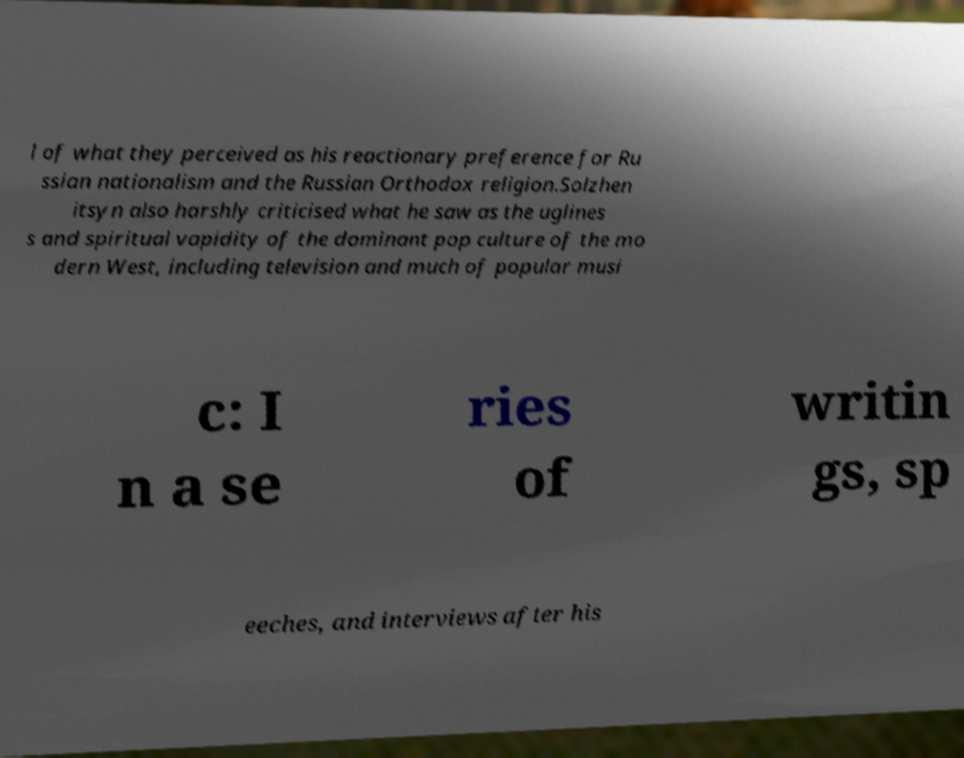What messages or text are displayed in this image? I need them in a readable, typed format. l of what they perceived as his reactionary preference for Ru ssian nationalism and the Russian Orthodox religion.Solzhen itsyn also harshly criticised what he saw as the uglines s and spiritual vapidity of the dominant pop culture of the mo dern West, including television and much of popular musi c: I n a se ries of writin gs, sp eeches, and interviews after his 